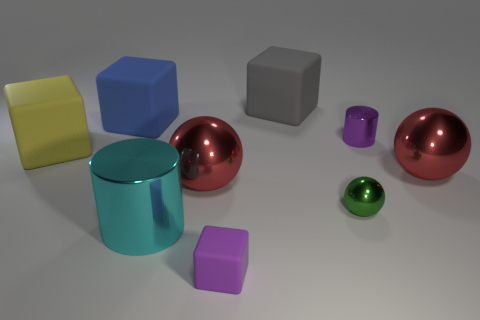There is a large yellow object in front of the large gray matte cube; is there a tiny purple metallic cylinder on the right side of it?
Ensure brevity in your answer.  Yes. Do the red shiny thing that is to the right of the small purple cylinder and the small green metallic object have the same shape?
Ensure brevity in your answer.  Yes. What number of cylinders are either red shiny objects or tiny rubber things?
Offer a terse response. 0. What number of big rubber cubes are there?
Your response must be concise. 3. What size is the purple thing in front of the cylinder behind the small ball?
Ensure brevity in your answer.  Small. What number of other objects are the same size as the cyan object?
Your response must be concise. 5. There is a gray rubber thing; how many metallic cylinders are in front of it?
Offer a terse response. 2. The gray rubber block has what size?
Give a very brief answer. Large. Does the large red sphere that is to the right of the purple cube have the same material as the red sphere to the left of the small cube?
Provide a succinct answer. Yes. Are there any metallic cylinders that have the same color as the small cube?
Keep it short and to the point. Yes. 